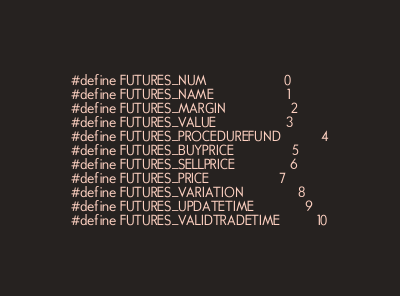Convert code to text. <code><loc_0><loc_0><loc_500><loc_500><_C_>
#define FUTURES_NUM                     0
#define FUTURES_NAME                    1
#define FUTURES_MARGIN                  2
#define FUTURES_VALUE                   3
#define FUTURES_PROCEDUREFUND           4
#define FUTURES_BUYPRICE                5
#define FUTURES_SELLPRICE               6
#define FUTURES_PRICE                   7
#define FUTURES_VARIATION               8
#define FUTURES_UPDATETIME              9
#define FUTURES_VALIDTRADETIME          10


</code> 